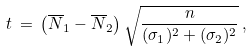<formula> <loc_0><loc_0><loc_500><loc_500>t \, = \, \left ( \overline { N } _ { 1 } - \overline { N } _ { 2 } \right ) \sqrt { \frac { n } { ( \sigma _ { 1 } ) ^ { 2 } + ( \sigma _ { 2 } ) ^ { 2 } } } \, ,</formula> 